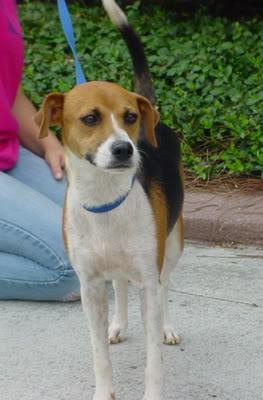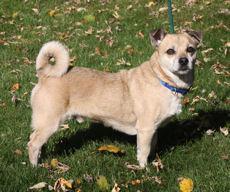The first image is the image on the left, the second image is the image on the right. Given the left and right images, does the statement "One image shows a dog with a tail curled inward, standing on all fours with its body in profile and wearing a collar." hold true? Answer yes or no. Yes. The first image is the image on the left, the second image is the image on the right. For the images displayed, is the sentence "One dog is on a leash." factually correct? Answer yes or no. Yes. 